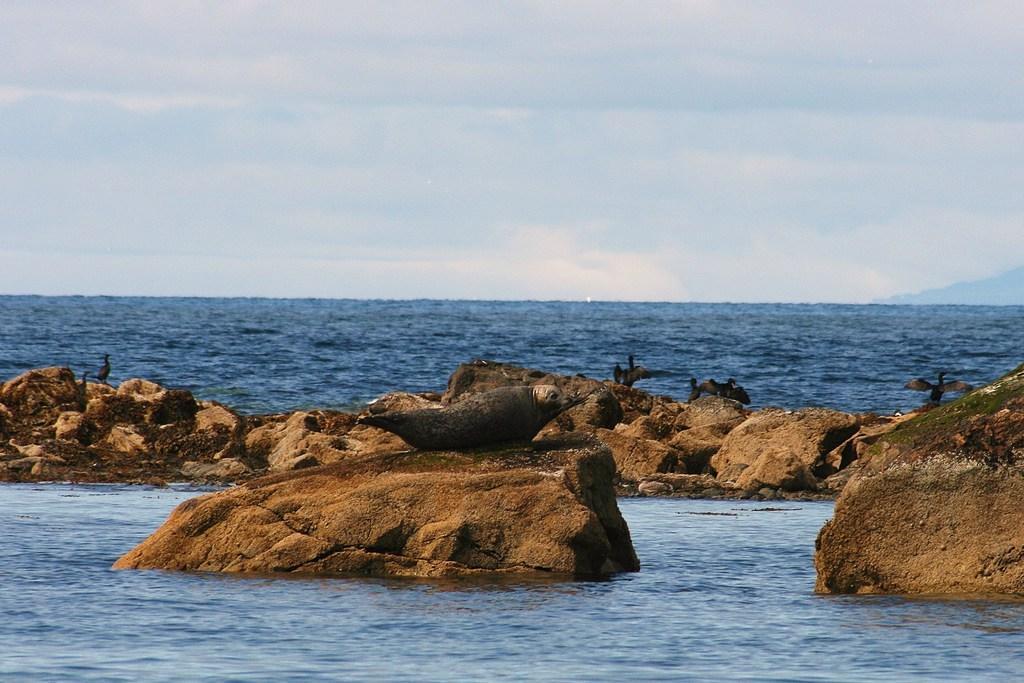How would you summarize this image in a sentence or two? In this image we can see a few birds on the rocks and also we can see the water, in the background we can see the sky with clouds. 